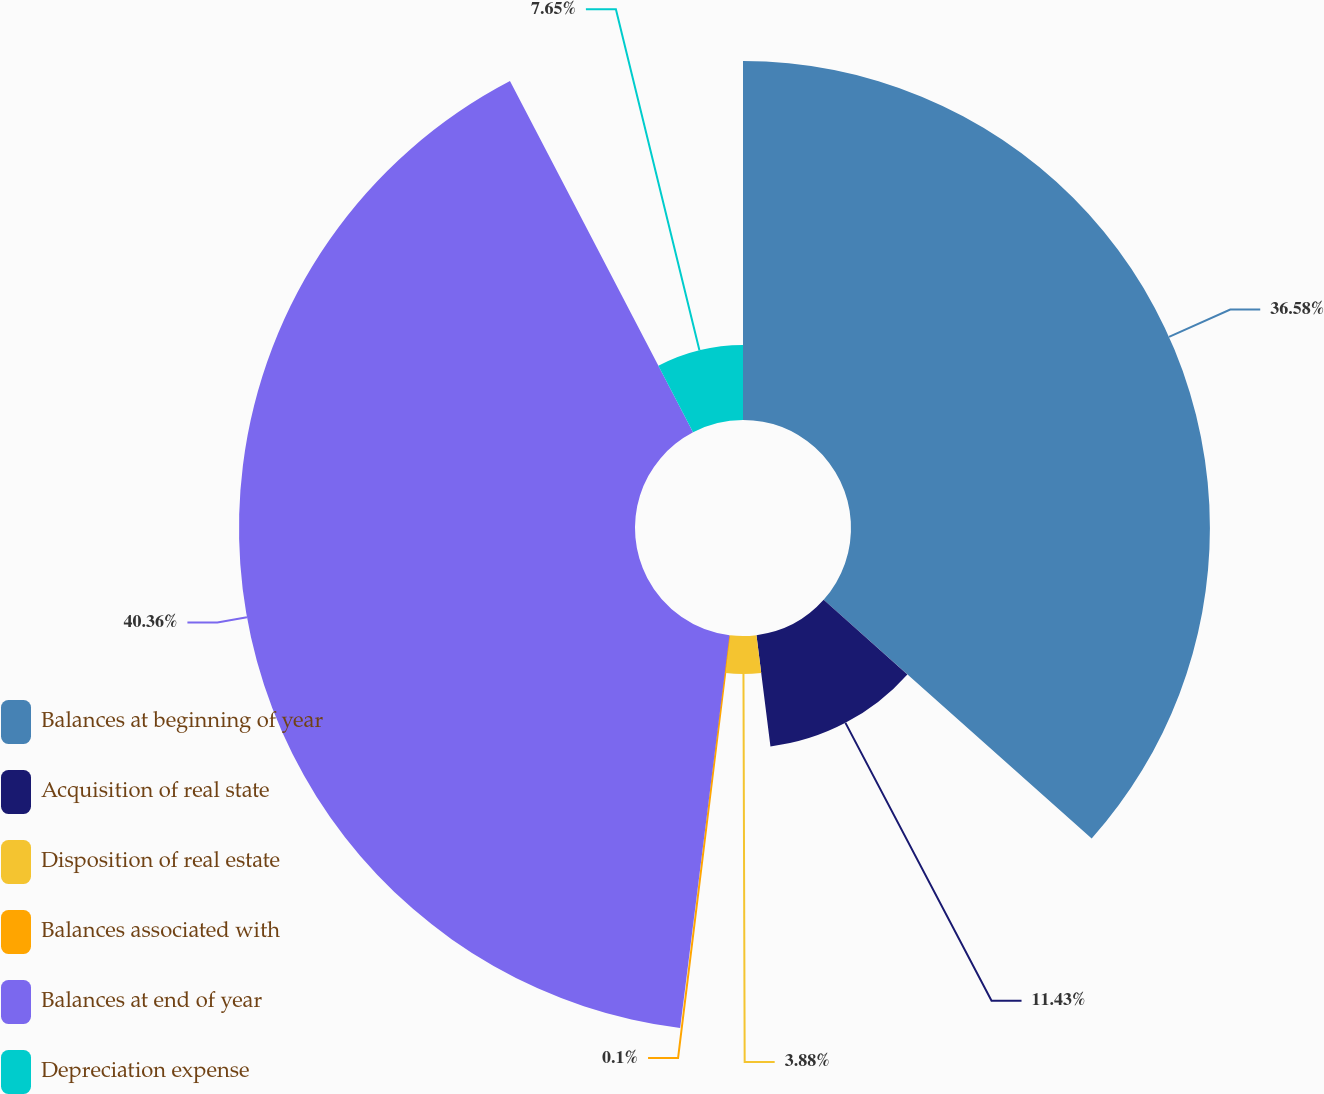<chart> <loc_0><loc_0><loc_500><loc_500><pie_chart><fcel>Balances at beginning of year<fcel>Acquisition of real state<fcel>Disposition of real estate<fcel>Balances associated with<fcel>Balances at end of year<fcel>Depreciation expense<nl><fcel>36.58%<fcel>11.43%<fcel>3.88%<fcel>0.1%<fcel>40.36%<fcel>7.65%<nl></chart> 